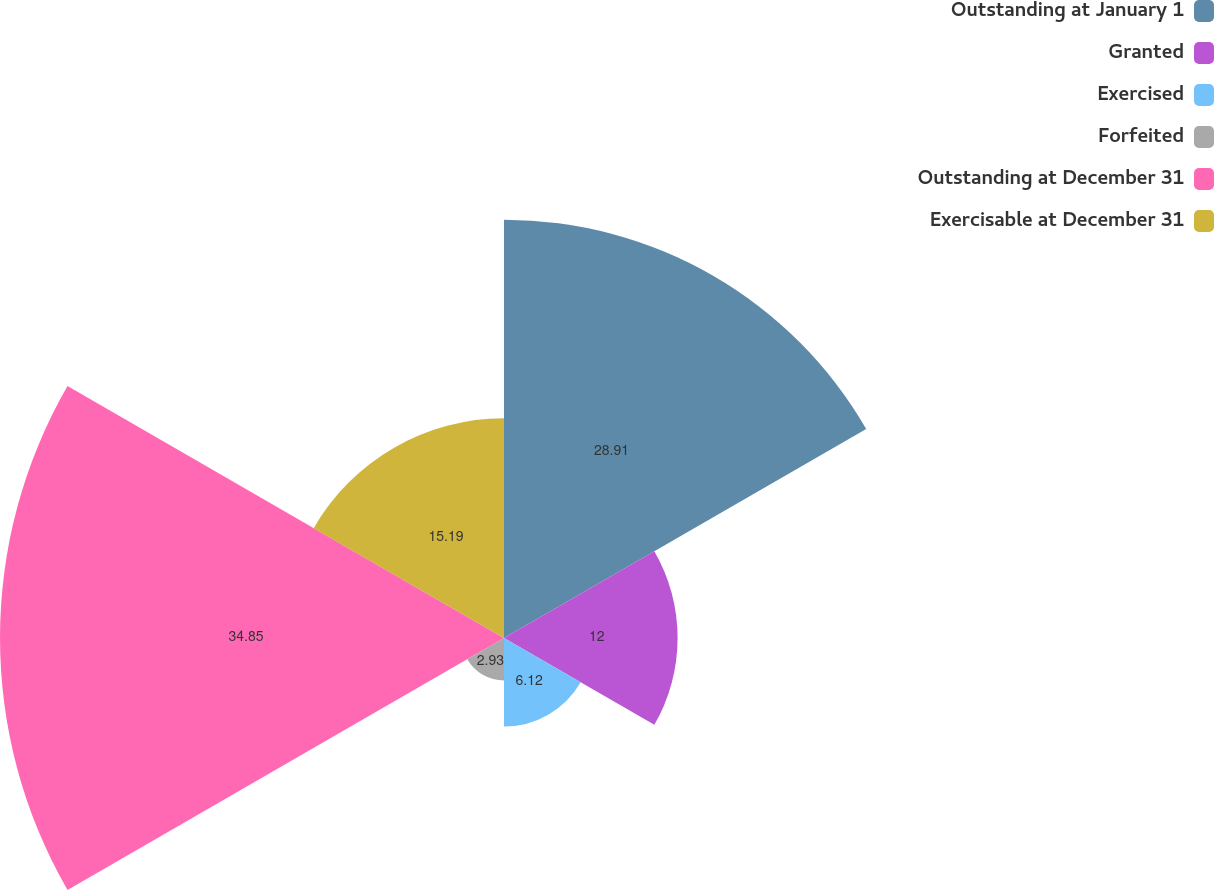<chart> <loc_0><loc_0><loc_500><loc_500><pie_chart><fcel>Outstanding at January 1<fcel>Granted<fcel>Exercised<fcel>Forfeited<fcel>Outstanding at December 31<fcel>Exercisable at December 31<nl><fcel>28.91%<fcel>12.0%<fcel>6.12%<fcel>2.93%<fcel>34.84%<fcel>15.19%<nl></chart> 